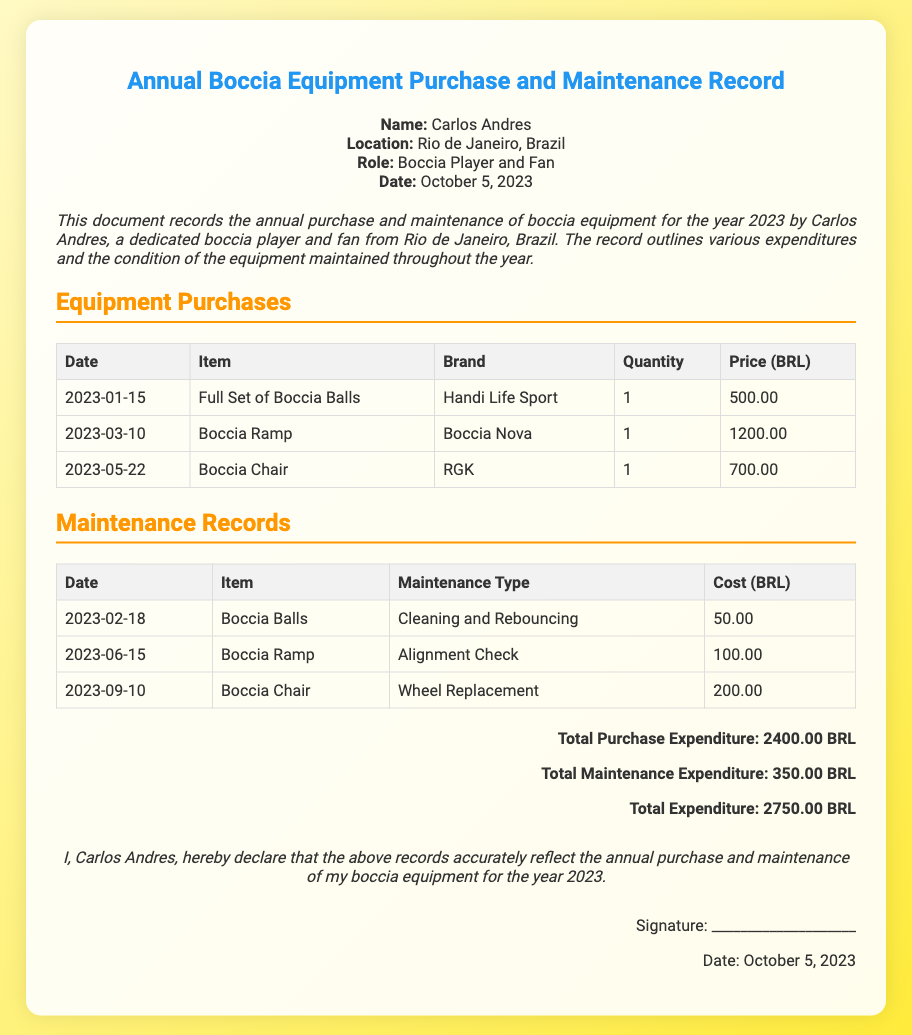What is the name of the individual? The document states the individual's name as Carlos Andres.
Answer: Carlos Andres What location is mentioned in the document? The document specifies the location as Rio de Janeiro, Brazil.
Answer: Rio de Janeiro, Brazil How much was spent on the Boccia Ramp? The purchase price for the Boccia Ramp listed in the document is 1200.00 BRL.
Answer: 1200.00 BRL What is the total expenditure for maintenance? The document lists the total maintenance expenditure as 350.00 BRL.
Answer: 350.00 BRL What type of maintenance was done on the Boccia Chair? The maintenance type for the Boccia Chair recorded is Wheel Replacement.
Answer: Wheel Replacement How many items were purchased in total? The document lists three items purchased: Boccia Balls, Boccia Ramp, and Boccia Chair.
Answer: 3 What is the date of the declaration? The signature date mentioned in the document is October 5, 2023.
Answer: October 5, 2023 What does the individual declare about the records? Carlos Andres states that the records accurately reflect the annual purchase and maintenance of his boccia equipment.
Answer: Accurately reflect the annual purchase and maintenance of boccia equipment What was the date of the first equipment purchase? The document indicates the first equipment purchase date as January 15, 2023.
Answer: January 15, 2023 